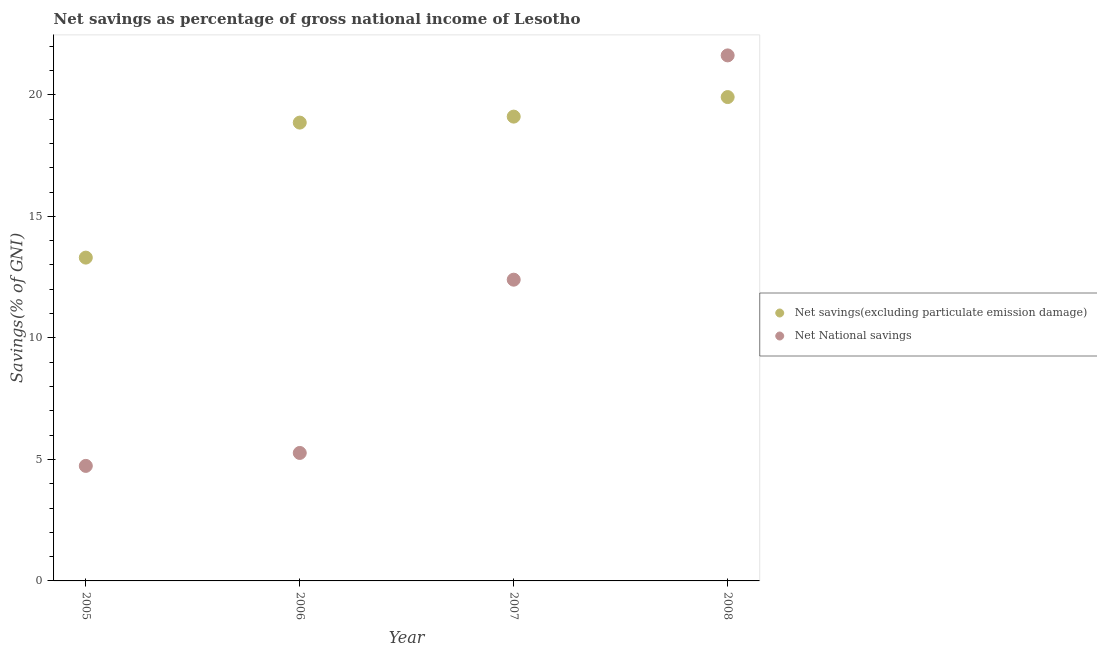Is the number of dotlines equal to the number of legend labels?
Offer a terse response. Yes. What is the net national savings in 2005?
Keep it short and to the point. 4.73. Across all years, what is the maximum net national savings?
Your response must be concise. 21.62. Across all years, what is the minimum net national savings?
Your answer should be compact. 4.73. In which year was the net national savings maximum?
Give a very brief answer. 2008. What is the total net savings(excluding particulate emission damage) in the graph?
Make the answer very short. 71.17. What is the difference between the net savings(excluding particulate emission damage) in 2005 and that in 2007?
Make the answer very short. -5.8. What is the difference between the net savings(excluding particulate emission damage) in 2006 and the net national savings in 2005?
Give a very brief answer. 14.12. What is the average net savings(excluding particulate emission damage) per year?
Ensure brevity in your answer.  17.79. In the year 2005, what is the difference between the net national savings and net savings(excluding particulate emission damage)?
Make the answer very short. -8.57. What is the ratio of the net savings(excluding particulate emission damage) in 2006 to that in 2008?
Ensure brevity in your answer.  0.95. Is the difference between the net savings(excluding particulate emission damage) in 2005 and 2007 greater than the difference between the net national savings in 2005 and 2007?
Make the answer very short. Yes. What is the difference between the highest and the second highest net national savings?
Offer a terse response. 9.23. What is the difference between the highest and the lowest net national savings?
Provide a short and direct response. 16.89. In how many years, is the net savings(excluding particulate emission damage) greater than the average net savings(excluding particulate emission damage) taken over all years?
Provide a short and direct response. 3. Is the sum of the net national savings in 2006 and 2007 greater than the maximum net savings(excluding particulate emission damage) across all years?
Give a very brief answer. No. Is the net savings(excluding particulate emission damage) strictly greater than the net national savings over the years?
Offer a very short reply. No. Is the net savings(excluding particulate emission damage) strictly less than the net national savings over the years?
Your answer should be very brief. No. Are the values on the major ticks of Y-axis written in scientific E-notation?
Offer a very short reply. No. What is the title of the graph?
Make the answer very short. Net savings as percentage of gross national income of Lesotho. What is the label or title of the Y-axis?
Offer a very short reply. Savings(% of GNI). What is the Savings(% of GNI) in Net savings(excluding particulate emission damage) in 2005?
Provide a succinct answer. 13.3. What is the Savings(% of GNI) in Net National savings in 2005?
Keep it short and to the point. 4.73. What is the Savings(% of GNI) of Net savings(excluding particulate emission damage) in 2006?
Your response must be concise. 18.86. What is the Savings(% of GNI) of Net National savings in 2006?
Provide a short and direct response. 5.26. What is the Savings(% of GNI) in Net savings(excluding particulate emission damage) in 2007?
Your response must be concise. 19.1. What is the Savings(% of GNI) in Net National savings in 2007?
Keep it short and to the point. 12.39. What is the Savings(% of GNI) of Net savings(excluding particulate emission damage) in 2008?
Your answer should be compact. 19.91. What is the Savings(% of GNI) in Net National savings in 2008?
Ensure brevity in your answer.  21.62. Across all years, what is the maximum Savings(% of GNI) in Net savings(excluding particulate emission damage)?
Offer a very short reply. 19.91. Across all years, what is the maximum Savings(% of GNI) of Net National savings?
Provide a short and direct response. 21.62. Across all years, what is the minimum Savings(% of GNI) in Net savings(excluding particulate emission damage)?
Your response must be concise. 13.3. Across all years, what is the minimum Savings(% of GNI) of Net National savings?
Offer a very short reply. 4.73. What is the total Savings(% of GNI) of Net savings(excluding particulate emission damage) in the graph?
Provide a succinct answer. 71.17. What is the total Savings(% of GNI) in Net National savings in the graph?
Provide a short and direct response. 44.01. What is the difference between the Savings(% of GNI) of Net savings(excluding particulate emission damage) in 2005 and that in 2006?
Keep it short and to the point. -5.55. What is the difference between the Savings(% of GNI) of Net National savings in 2005 and that in 2006?
Offer a very short reply. -0.53. What is the difference between the Savings(% of GNI) of Net savings(excluding particulate emission damage) in 2005 and that in 2007?
Ensure brevity in your answer.  -5.8. What is the difference between the Savings(% of GNI) of Net National savings in 2005 and that in 2007?
Offer a terse response. -7.66. What is the difference between the Savings(% of GNI) in Net savings(excluding particulate emission damage) in 2005 and that in 2008?
Offer a terse response. -6.61. What is the difference between the Savings(% of GNI) in Net National savings in 2005 and that in 2008?
Your answer should be very brief. -16.89. What is the difference between the Savings(% of GNI) of Net savings(excluding particulate emission damage) in 2006 and that in 2007?
Make the answer very short. -0.25. What is the difference between the Savings(% of GNI) in Net National savings in 2006 and that in 2007?
Ensure brevity in your answer.  -7.13. What is the difference between the Savings(% of GNI) in Net savings(excluding particulate emission damage) in 2006 and that in 2008?
Your response must be concise. -1.05. What is the difference between the Savings(% of GNI) of Net National savings in 2006 and that in 2008?
Give a very brief answer. -16.36. What is the difference between the Savings(% of GNI) of Net savings(excluding particulate emission damage) in 2007 and that in 2008?
Your response must be concise. -0.8. What is the difference between the Savings(% of GNI) of Net National savings in 2007 and that in 2008?
Offer a terse response. -9.23. What is the difference between the Savings(% of GNI) of Net savings(excluding particulate emission damage) in 2005 and the Savings(% of GNI) of Net National savings in 2006?
Your response must be concise. 8.04. What is the difference between the Savings(% of GNI) in Net savings(excluding particulate emission damage) in 2005 and the Savings(% of GNI) in Net National savings in 2007?
Keep it short and to the point. 0.91. What is the difference between the Savings(% of GNI) of Net savings(excluding particulate emission damage) in 2005 and the Savings(% of GNI) of Net National savings in 2008?
Provide a succinct answer. -8.32. What is the difference between the Savings(% of GNI) in Net savings(excluding particulate emission damage) in 2006 and the Savings(% of GNI) in Net National savings in 2007?
Provide a short and direct response. 6.46. What is the difference between the Savings(% of GNI) of Net savings(excluding particulate emission damage) in 2006 and the Savings(% of GNI) of Net National savings in 2008?
Keep it short and to the point. -2.76. What is the difference between the Savings(% of GNI) of Net savings(excluding particulate emission damage) in 2007 and the Savings(% of GNI) of Net National savings in 2008?
Your response must be concise. -2.52. What is the average Savings(% of GNI) in Net savings(excluding particulate emission damage) per year?
Keep it short and to the point. 17.79. What is the average Savings(% of GNI) of Net National savings per year?
Your answer should be very brief. 11. In the year 2005, what is the difference between the Savings(% of GNI) of Net savings(excluding particulate emission damage) and Savings(% of GNI) of Net National savings?
Ensure brevity in your answer.  8.57. In the year 2006, what is the difference between the Savings(% of GNI) in Net savings(excluding particulate emission damage) and Savings(% of GNI) in Net National savings?
Your answer should be very brief. 13.59. In the year 2007, what is the difference between the Savings(% of GNI) of Net savings(excluding particulate emission damage) and Savings(% of GNI) of Net National savings?
Offer a terse response. 6.71. In the year 2008, what is the difference between the Savings(% of GNI) in Net savings(excluding particulate emission damage) and Savings(% of GNI) in Net National savings?
Offer a very short reply. -1.71. What is the ratio of the Savings(% of GNI) in Net savings(excluding particulate emission damage) in 2005 to that in 2006?
Your answer should be compact. 0.71. What is the ratio of the Savings(% of GNI) in Net National savings in 2005 to that in 2006?
Keep it short and to the point. 0.9. What is the ratio of the Savings(% of GNI) of Net savings(excluding particulate emission damage) in 2005 to that in 2007?
Give a very brief answer. 0.7. What is the ratio of the Savings(% of GNI) in Net National savings in 2005 to that in 2007?
Make the answer very short. 0.38. What is the ratio of the Savings(% of GNI) in Net savings(excluding particulate emission damage) in 2005 to that in 2008?
Provide a succinct answer. 0.67. What is the ratio of the Savings(% of GNI) of Net National savings in 2005 to that in 2008?
Give a very brief answer. 0.22. What is the ratio of the Savings(% of GNI) of Net savings(excluding particulate emission damage) in 2006 to that in 2007?
Your response must be concise. 0.99. What is the ratio of the Savings(% of GNI) in Net National savings in 2006 to that in 2007?
Give a very brief answer. 0.42. What is the ratio of the Savings(% of GNI) of Net savings(excluding particulate emission damage) in 2006 to that in 2008?
Offer a very short reply. 0.95. What is the ratio of the Savings(% of GNI) of Net National savings in 2006 to that in 2008?
Keep it short and to the point. 0.24. What is the ratio of the Savings(% of GNI) of Net savings(excluding particulate emission damage) in 2007 to that in 2008?
Provide a short and direct response. 0.96. What is the ratio of the Savings(% of GNI) in Net National savings in 2007 to that in 2008?
Your answer should be very brief. 0.57. What is the difference between the highest and the second highest Savings(% of GNI) in Net savings(excluding particulate emission damage)?
Offer a very short reply. 0.8. What is the difference between the highest and the second highest Savings(% of GNI) of Net National savings?
Offer a very short reply. 9.23. What is the difference between the highest and the lowest Savings(% of GNI) of Net savings(excluding particulate emission damage)?
Keep it short and to the point. 6.61. What is the difference between the highest and the lowest Savings(% of GNI) in Net National savings?
Offer a terse response. 16.89. 